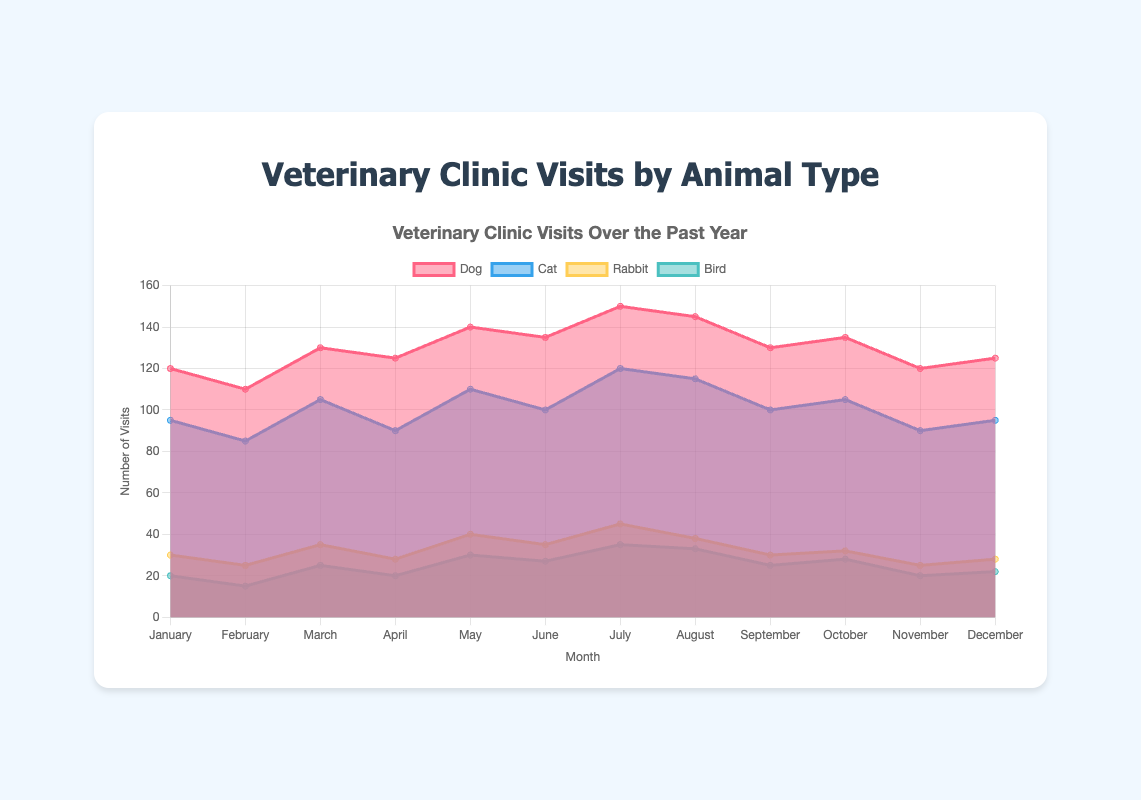What is the title of the figure? The title of the figure is prominently displayed at the top.
Answer: Veterinary Clinic Visits by Animal Type Which animal had the highest number of visits in July? By inspecting the chart for July, the dataset with the highest value corresponds to the 'Dog' category.
Answer: Dog How many visits did cats have in May? Locate the data point for 'Cat' in the month of May. The chart shows the value 110.
Answer: 110 During which month did rabbits have the least number of visits? Check all the data points for the rabbit category and find the smallest value. This value occurs in February.
Answer: February What is the total number of visits for birds in the first quarter (January to March)? Sum the bird data points for January (20), February (15), and March (25): 20 + 15 + 25 = 60.
Answer: 60 Compare the number of visits for dogs and cats in December. Which had more visits? Inspect the data points for both 'Dog' and 'Cat' in December. Dogs had 125 visits, while cats had 95.
Answer: Dog What is the average number of visits for rabbits across all months? Sum the rabbit data points for all months: 30 + 25 + 35 + 28 + 40 + 35 + 45 + 38 + 30 + 32 + 25 + 28 = 391. Divide this by the number of months (12): 391 / 12 ≈ 32.58.
Answer: 32.58 What month observed the highest total number of visits across all animals? For each month, sum the data points for all animals and identify the maximum. July has the highest sum with 150 (Dog) + 120 (Cat) + 45 (Rabbit) + 35 (Bird) = 350.
Answer: July Which animal had the most significant increase in visits from June to July? Calculate the differences for each animal between June and July: Dog (15), Cat (20), Rabbit (10), Bird (8). Cats had the greatest increase.
Answer: Cat How does the trend of bird visits compare to cat visits over the year? Bird visits show less fluctuation with a general increasing trend, while cat visits experience more variation with notable peaks in July and August.
Answer: Bird visits are steadier; cat visits are more varied 